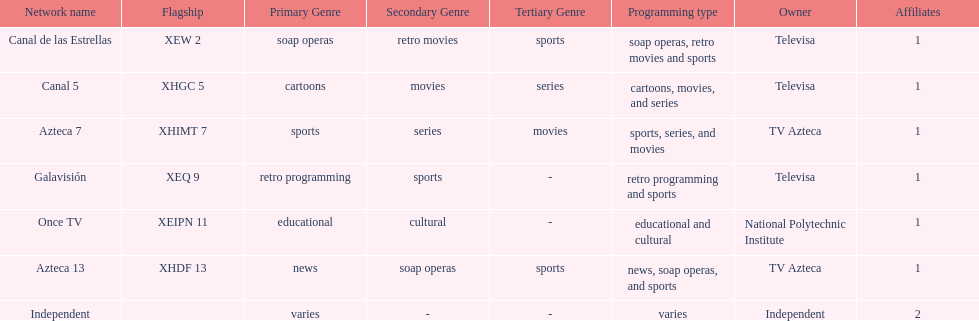How many networks does tv azteca own? 2. 